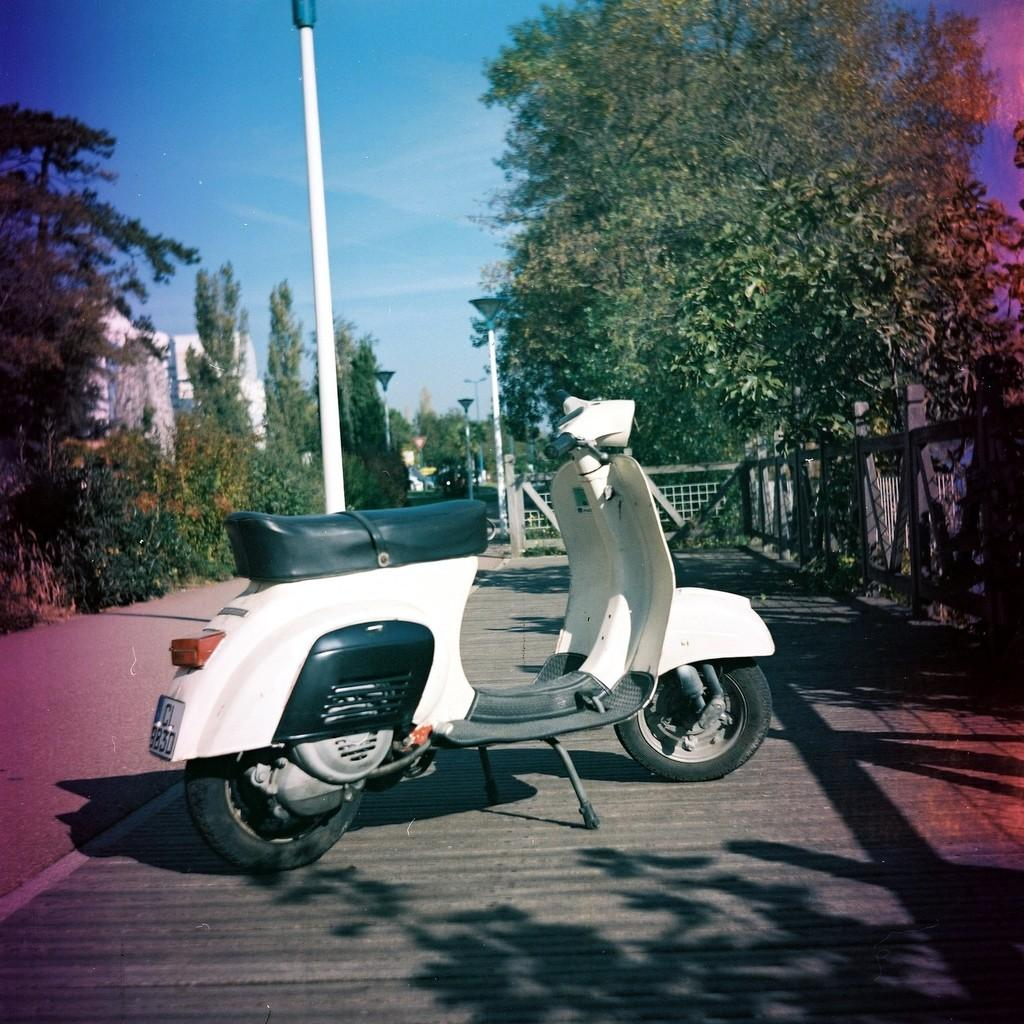What structures are present in the image? There are poles and fencing in the image. What objects are providing illumination in the image? There are lights in the image. What type of vehicle can be seen in the image? There is a motorcycle in the image. What type of vegetation is present in the image? There are plants and trees in the image. What part of the natural environment is visible in the image? The sky is visible in the image. Where is the cushion placed on the motorcycle in the image? There is no cushion present on the motorcycle in the image. What type of passenger can be seen riding the motorcycle in the image? There is no passenger visible on the motorcycle in the image. 